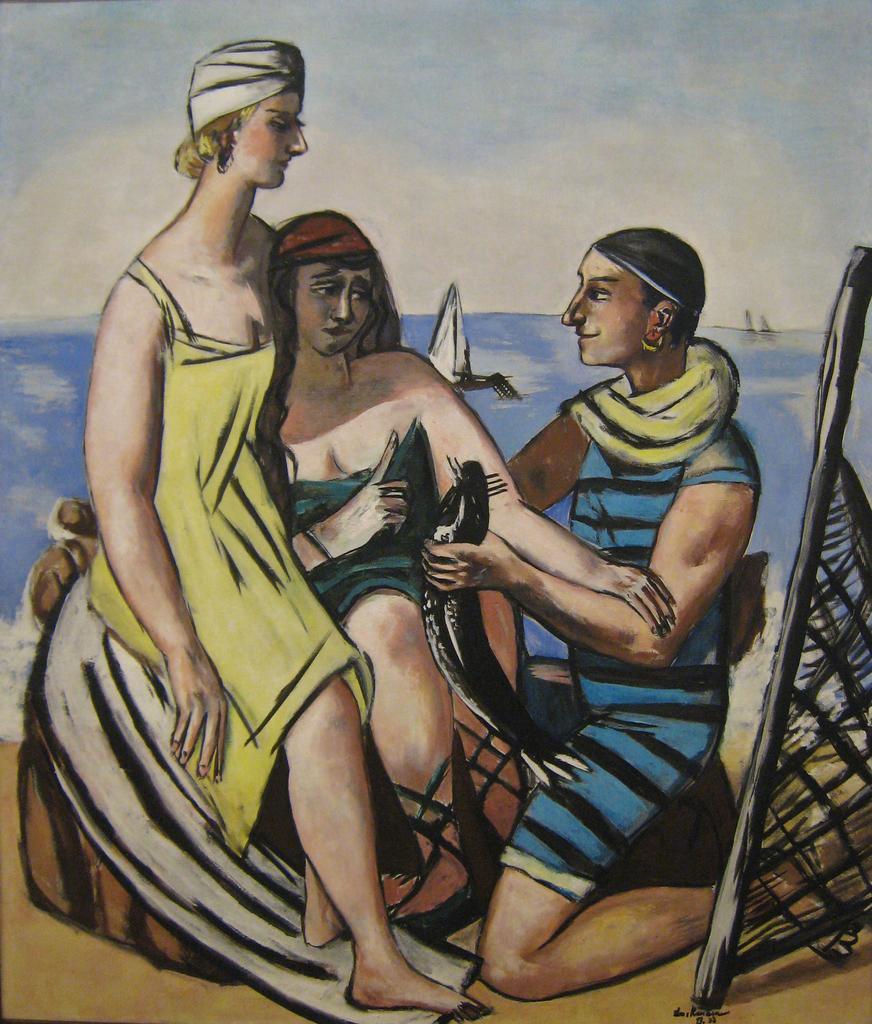How would you summarize this image in a sentence or two? In this picture we can see a painting, this is a painting of three persons, water and a boat. 